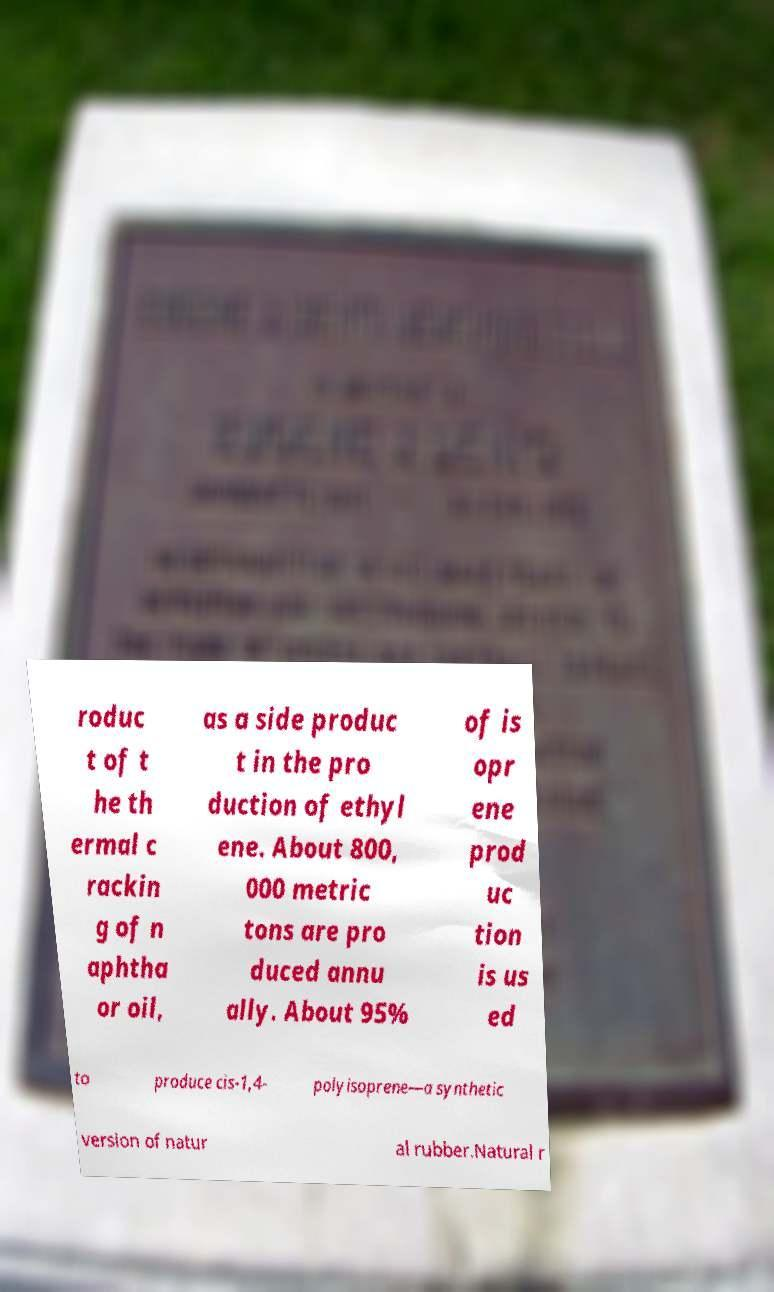Please identify and transcribe the text found in this image. roduc t of t he th ermal c rackin g of n aphtha or oil, as a side produc t in the pro duction of ethyl ene. About 800, 000 metric tons are pro duced annu ally. About 95% of is opr ene prod uc tion is us ed to produce cis-1,4- polyisoprene—a synthetic version of natur al rubber.Natural r 